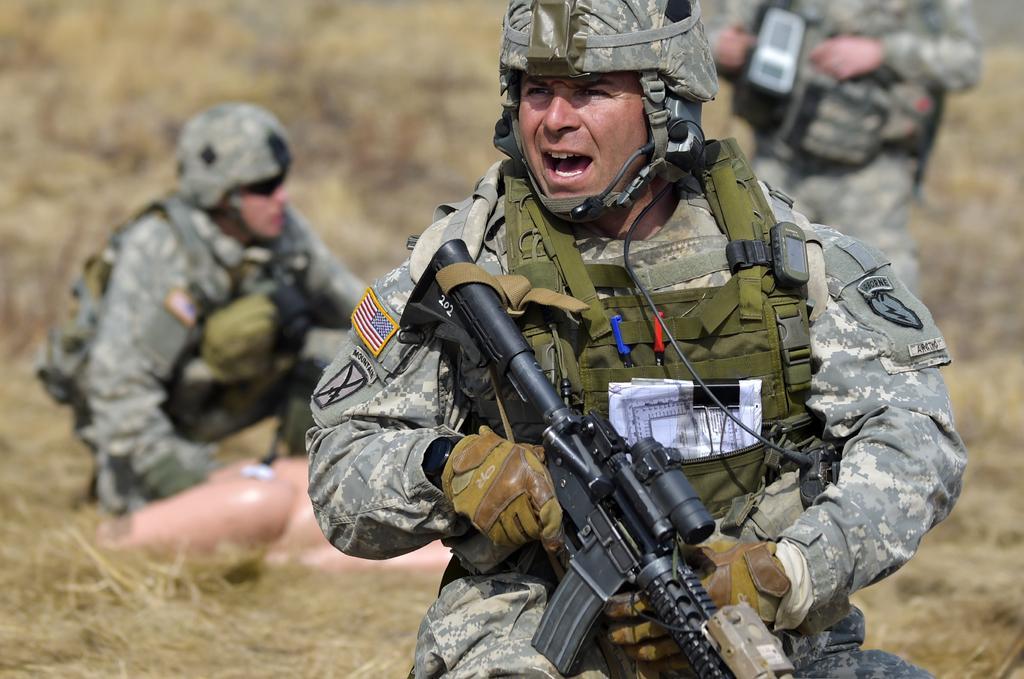In one or two sentences, can you explain what this image depicts? This picture describes about group of people, few people are holding guns, in the background we can see grass. 